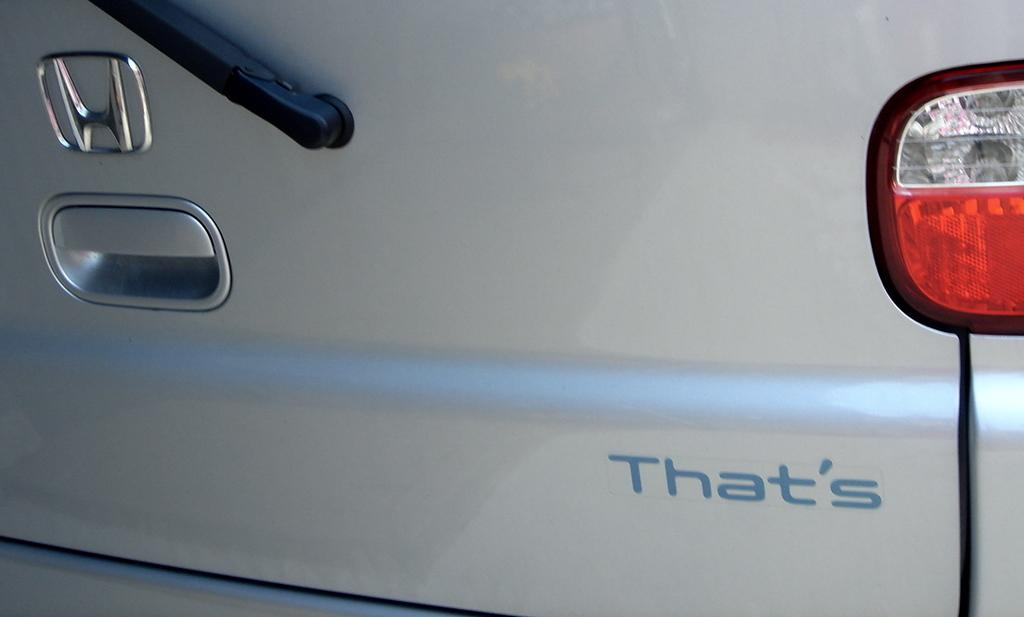What part of a car is shown in the image? There is a car back door in the image. What features can be seen on the car back door? The car back door has a logo, a handle, a light, and some writing. What type of scent can be detected coming from the car back door in the image? There is no indication of a scent in the image, as it only shows a car back door with various features. 